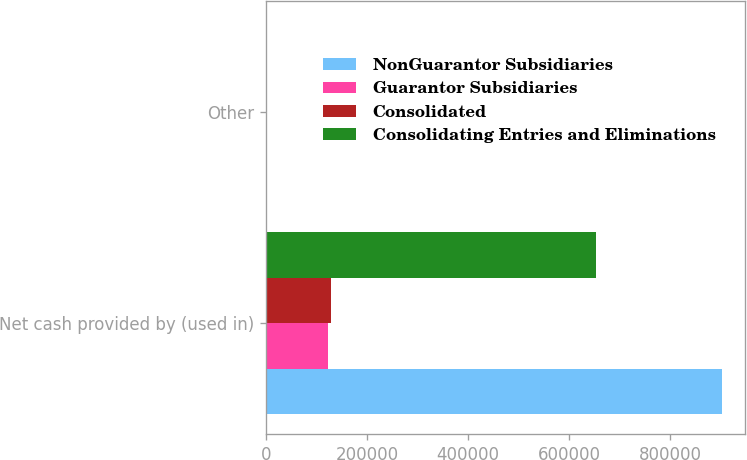Convert chart. <chart><loc_0><loc_0><loc_500><loc_500><stacked_bar_chart><ecel><fcel>Net cash provided by (used in)<fcel>Other<nl><fcel>NonGuarantor Subsidiaries<fcel>901525<fcel>1962<nl><fcel>Guarantor Subsidiaries<fcel>121956<fcel>566<nl><fcel>Consolidated<fcel>127772<fcel>541<nl><fcel>Consolidating Entries and Eliminations<fcel>652330<fcel>1148<nl></chart> 